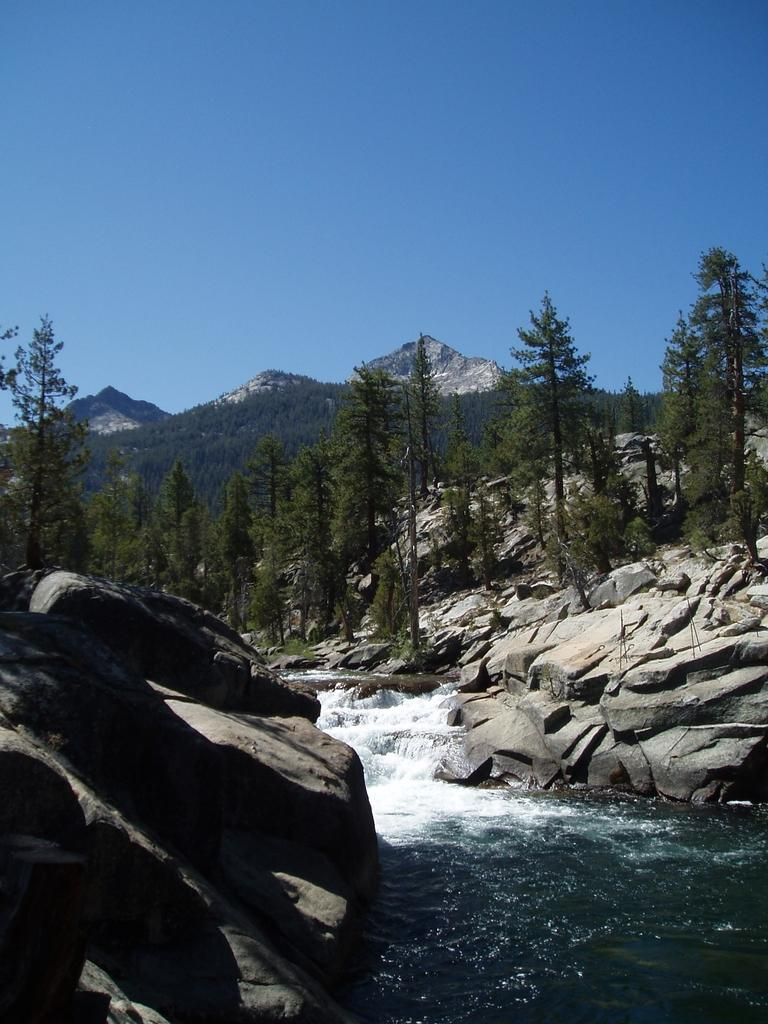What is flowing in the foreground of the image? There is a river flowing in the foreground of the image. What can be seen on either side of the river? There are rocks on either side of the river. What type of vegetation is visible in the background of the image? There are trees in the background of the image. What type of landscape feature is visible in the background of the image? There are mountains in the background of the image. What is visible at the top of the image? The sky is visible in the background of the image. What type of silverware is being used by the beggar in the image? There is no beggar present in the image, and therefore no silverware can be observed. 